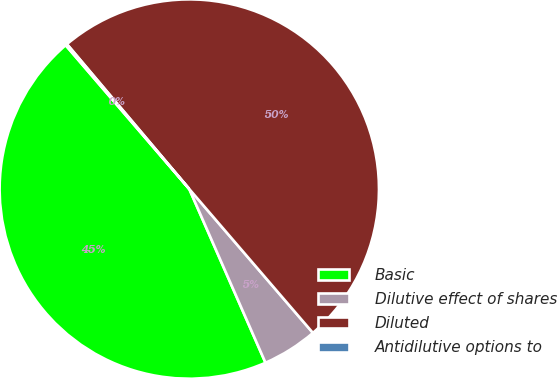<chart> <loc_0><loc_0><loc_500><loc_500><pie_chart><fcel>Basic<fcel>Dilutive effect of shares<fcel>Diluted<fcel>Antidilutive options to<nl><fcel>45.28%<fcel>4.72%<fcel>49.86%<fcel>0.14%<nl></chart> 